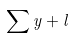Convert formula to latex. <formula><loc_0><loc_0><loc_500><loc_500>\sum { y + l }</formula> 